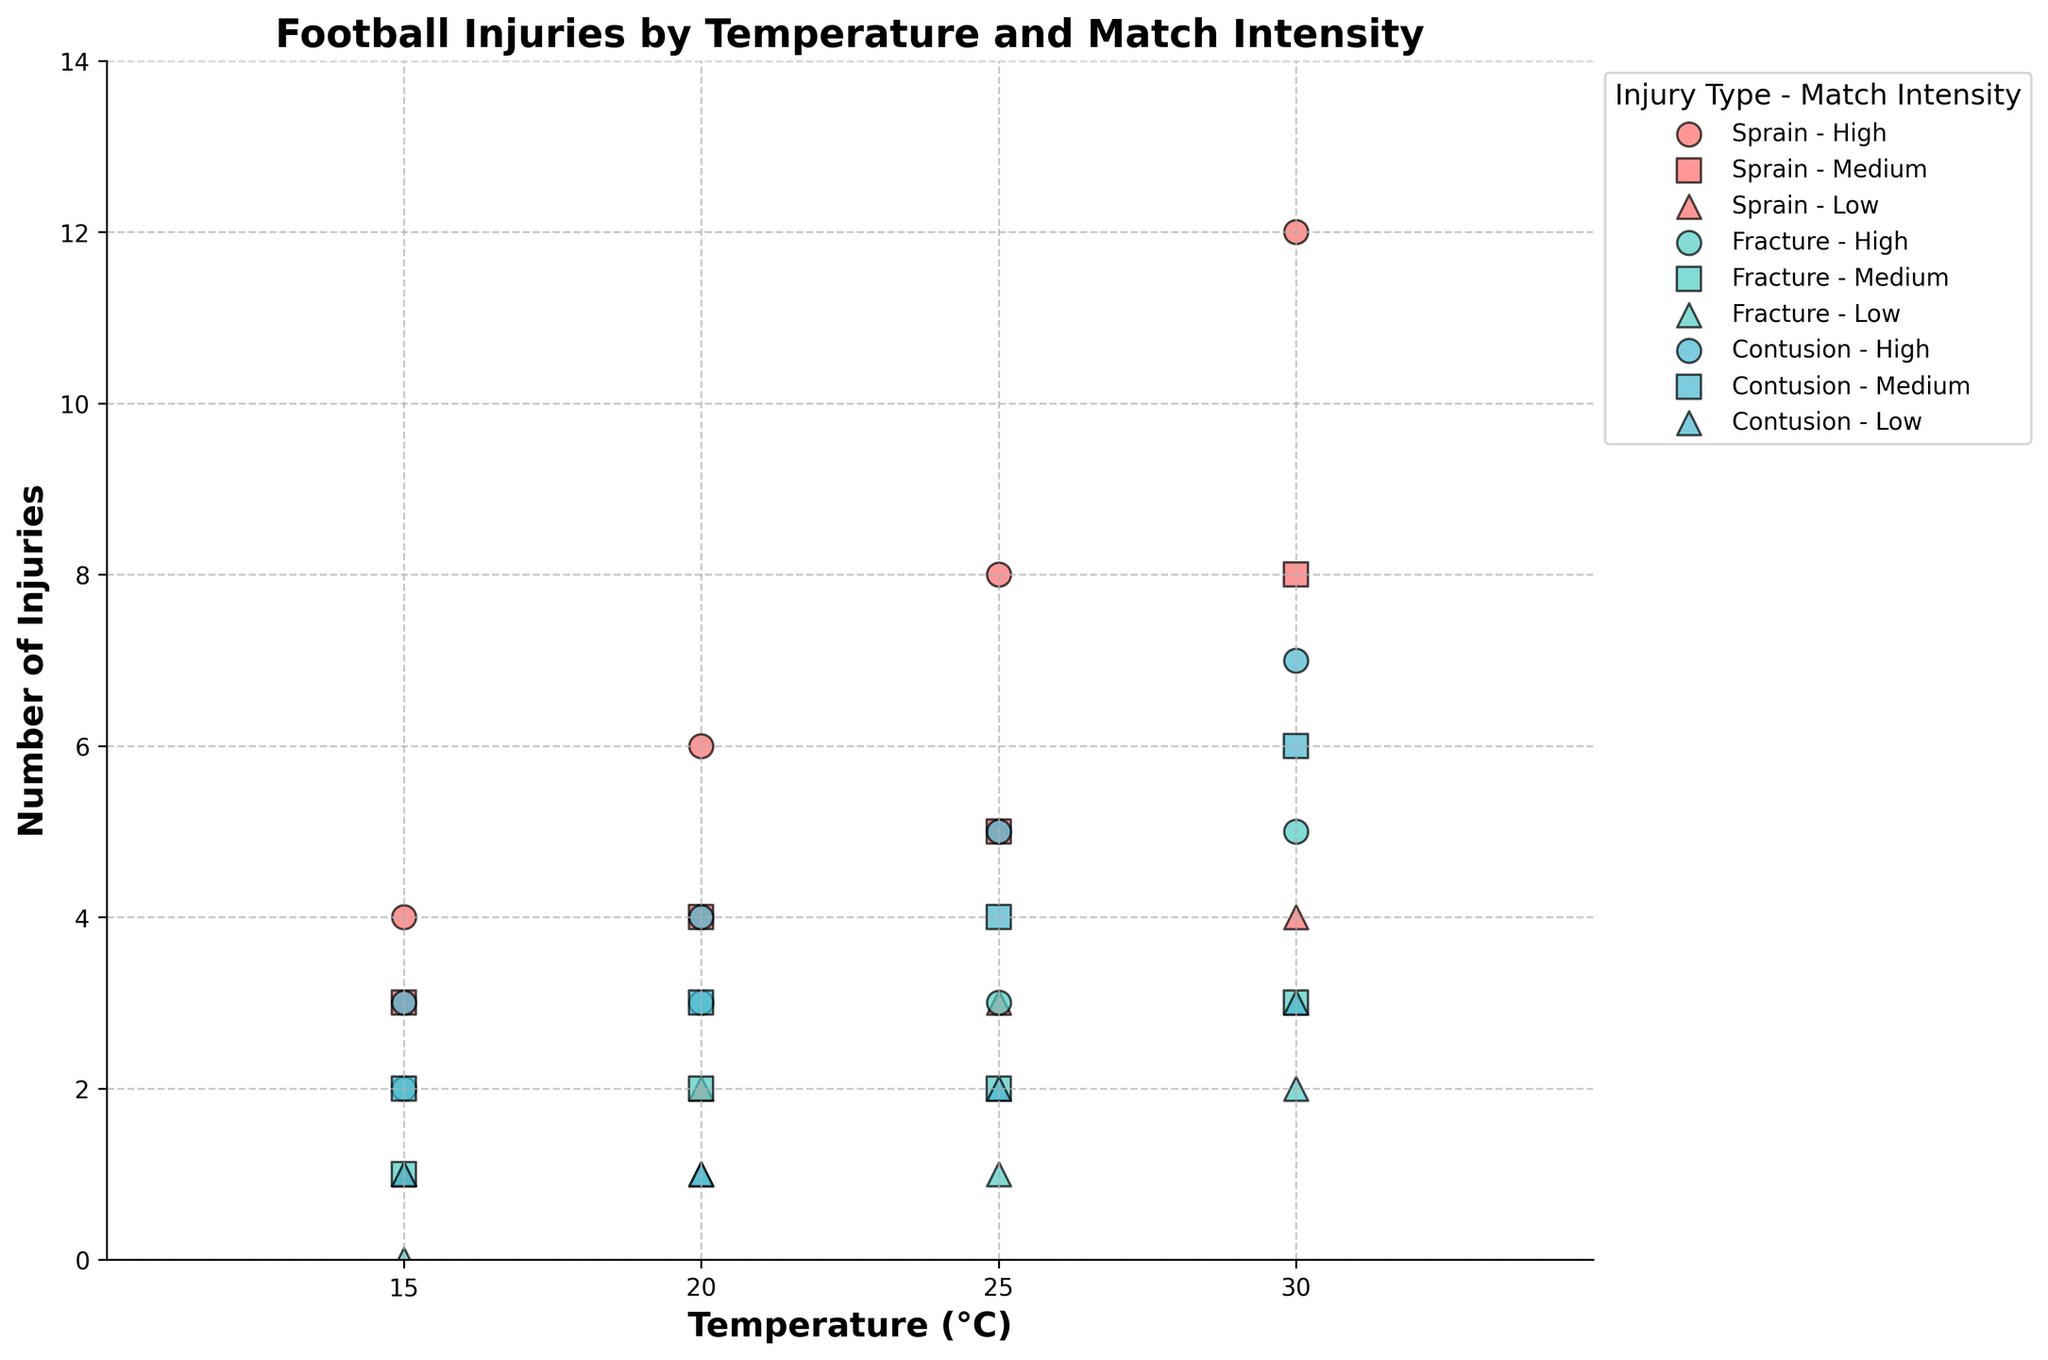What is the title of the figure? The title of the figure is usually displayed at the top center of the plot and it describes what the plot is about.
Answer: Football Injuries by Temperature and Match Intensity What axis values are plotted on the x-axis? The x-axis shows the temperatures at which the matches were played. The temperatures shown on the x-axis are usually marked as tick marks.
Answer: 15, 20, 25, 30 How many injury types are represented in the plot? There are three distinct colored markers in the plot, each representing a different type of injury.
Answer: 3 Which type of injury had the highest number of injuries at 30°C during high-intensity matches? Look at the data points corresponding to 30°C and High Match Intensity, then identify the type of injury with the highest value on the y-axis.
Answer: Sprain How do the number of sprains in low-intensity matches change as temperature increases? Observe the data points corresponding to 'Sprain' and 'Low' Match Intensity across different temperatures and note the trend.
Answer: Increases At what temperature and match intensity do we see the least number of total injuries? Sum the number of injuries for all types at each temperature and intensity combination, then find the lowest total.
Answer: 15°C, Low What is the total number of fractures recorded at 25°C? Locate the data points corresponding to 'Fracture' at 25°C and sum up the values across all match intensities.
Answer: 6 Compare the number of contusions between medium and high-intensity matches at 20°C. Which is higher? Identify the data points for 'Contusion' at 20°C for both Medium and High match intensities, and compare their values.
Answer: High Is there a pattern between match intensity and the number of injuries observed? Observe the distribution of data points across different match intensities to identify any trends. Typically, higher match intensity should correlate with an increased number of injuries.
Answer: Higher intensity tends to have more injuries Which type of injury appears to be most affected by changes in match intensity? Compare the variation in the number of different types of injuries across different match intensities to find which one shows the most change.
Answer: Sprain 